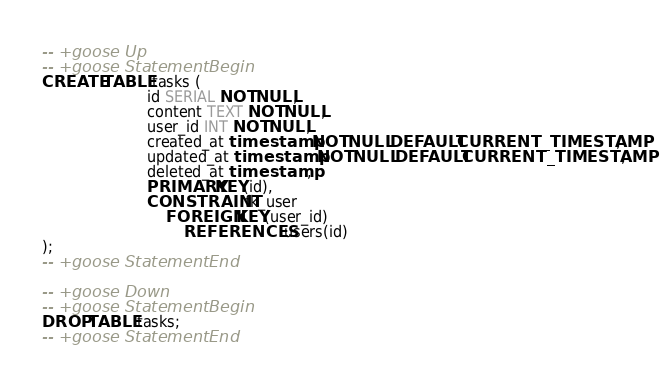Convert code to text. <code><loc_0><loc_0><loc_500><loc_500><_SQL_>-- +goose Up
-- +goose StatementBegin
CREATE TABLE tasks (
                       id SERIAL NOT NULL,
                       content TEXT NOT NULL,
                       user_id INT NOT NULL,
                       created_at timestamp NOT NULL DEFAULT CURRENT_TIMESTAMP,
                       updated_at timestamp NOT NULL DEFAULT CURRENT_TIMESTAMP,
                       deleted_at timestamp,
                       PRIMARY KEY(id),
                       CONSTRAINT fk_user
                           FOREIGN KEY(user_id)
                               REFERENCES users(id)
);
-- +goose StatementEnd

-- +goose Down
-- +goose StatementBegin
DROP TABLE tasks;
-- +goose StatementEnd
</code> 